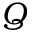Convert formula to latex. <formula><loc_0><loc_0><loc_500><loc_500>Q</formula> 